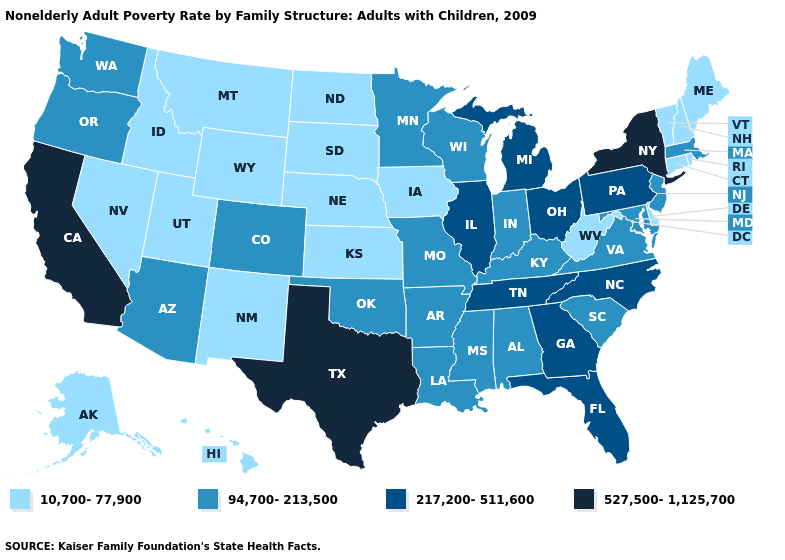Is the legend a continuous bar?
Concise answer only. No. Name the states that have a value in the range 94,700-213,500?
Answer briefly. Alabama, Arizona, Arkansas, Colorado, Indiana, Kentucky, Louisiana, Maryland, Massachusetts, Minnesota, Mississippi, Missouri, New Jersey, Oklahoma, Oregon, South Carolina, Virginia, Washington, Wisconsin. What is the value of Maryland?
Short answer required. 94,700-213,500. Name the states that have a value in the range 527,500-1,125,700?
Answer briefly. California, New York, Texas. Does Arizona have the same value as Texas?
Keep it brief. No. Name the states that have a value in the range 94,700-213,500?
Keep it brief. Alabama, Arizona, Arkansas, Colorado, Indiana, Kentucky, Louisiana, Maryland, Massachusetts, Minnesota, Mississippi, Missouri, New Jersey, Oklahoma, Oregon, South Carolina, Virginia, Washington, Wisconsin. What is the value of New Mexico?
Give a very brief answer. 10,700-77,900. Does North Dakota have the same value as New Mexico?
Quick response, please. Yes. What is the value of Montana?
Be succinct. 10,700-77,900. Name the states that have a value in the range 94,700-213,500?
Short answer required. Alabama, Arizona, Arkansas, Colorado, Indiana, Kentucky, Louisiana, Maryland, Massachusetts, Minnesota, Mississippi, Missouri, New Jersey, Oklahoma, Oregon, South Carolina, Virginia, Washington, Wisconsin. Among the states that border New Mexico , which have the lowest value?
Concise answer only. Utah. Does Nebraska have a lower value than Mississippi?
Quick response, please. Yes. Name the states that have a value in the range 527,500-1,125,700?
Be succinct. California, New York, Texas. What is the value of Rhode Island?
Give a very brief answer. 10,700-77,900. Among the states that border Tennessee , does Virginia have the highest value?
Short answer required. No. 